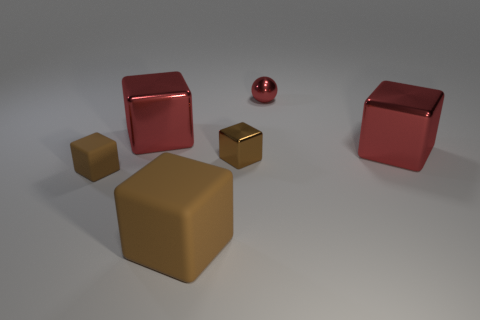There is a small thing that is behind the brown metal block; does it have the same color as the shiny thing on the left side of the big brown object?
Your answer should be compact. Yes. What number of red objects are metallic things or balls?
Offer a terse response. 3. Are there fewer brown metal cubes on the left side of the large brown matte block than tiny brown metallic blocks that are on the left side of the brown metallic object?
Your response must be concise. No. Are there any cyan balls of the same size as the red metal ball?
Offer a very short reply. No. Does the metallic thing right of the red metal ball have the same size as the large brown matte block?
Ensure brevity in your answer.  Yes. Is the number of brown matte cubes greater than the number of red balls?
Keep it short and to the point. Yes. Is there a small red thing that has the same shape as the small brown rubber thing?
Keep it short and to the point. No. What is the shape of the large thing in front of the brown metallic object?
Your answer should be compact. Cube. There is a big red shiny cube to the left of the tiny block that is right of the large brown rubber object; what number of large metallic blocks are on the left side of it?
Offer a very short reply. 0. There is a metal ball that is behind the tiny brown matte thing; is it the same color as the small matte object?
Keep it short and to the point. No. 